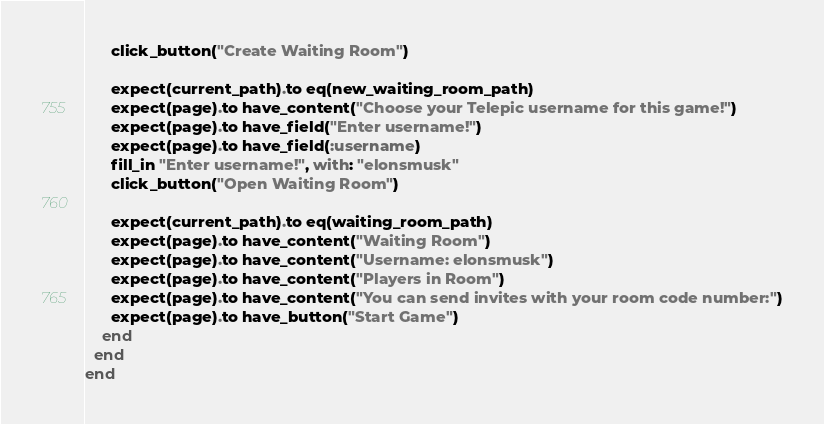<code> <loc_0><loc_0><loc_500><loc_500><_Ruby_>      click_button("Create Waiting Room")

      expect(current_path).to eq(new_waiting_room_path)
      expect(page).to have_content("Choose your Telepic username for this game!")
      expect(page).to have_field("Enter username!")
      expect(page).to have_field(:username)
      fill_in "Enter username!", with: "elonsmusk"
      click_button("Open Waiting Room")

      expect(current_path).to eq(waiting_room_path)
      expect(page).to have_content("Waiting Room")
      expect(page).to have_content("Username: elonsmusk")
      expect(page).to have_content("Players in Room")
      expect(page).to have_content("You can send invites with your room code number:")
      expect(page).to have_button("Start Game")
    end
  end
end
</code> 